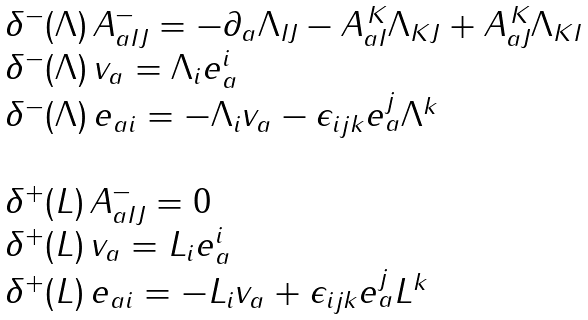Convert formula to latex. <formula><loc_0><loc_0><loc_500><loc_500>\begin{array} { l } \begin{array} { l } \delta ^ { - } ( \Lambda ) \, A ^ { - } _ { a I J } = - \partial _ { a } \Lambda _ { I J } - A _ { a I } ^ { \, K } \Lambda _ { K J } + A _ { a J } ^ { \, K } \Lambda _ { K I } \\ \delta ^ { - } ( \Lambda ) \, v _ { a } = \Lambda _ { i } e _ { a } ^ { i } \\ \delta ^ { - } ( \Lambda ) \, e _ { a i } = - \Lambda _ { i } v _ { a } - \epsilon _ { i j k } e _ { a } ^ { j } \Lambda ^ { k } \end{array} \\ \\ \begin{array} { l } \delta ^ { + } ( L ) \, A ^ { - } _ { a I J } = 0 \\ \delta ^ { + } ( L ) \, v _ { a } = L _ { i } e _ { a } ^ { i } \\ \delta ^ { + } ( L ) \, e _ { a i } = - L _ { i } v _ { a } + \epsilon _ { i j k } e _ { a } ^ { j } L ^ { k } \end{array} \end{array}</formula> 